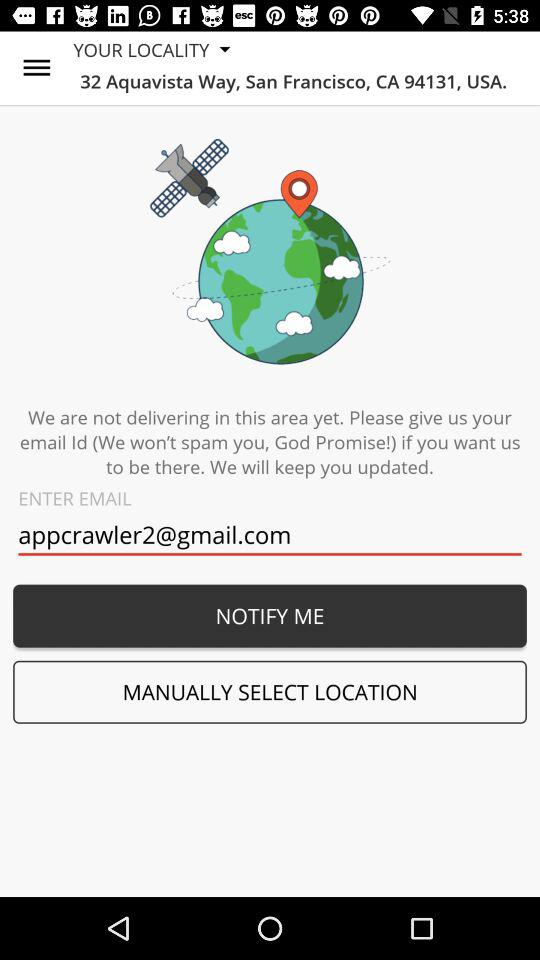What is the address of the locality? The address of the locality is 32 Aquavista Way, San Francisco, CA 94131, USA. 